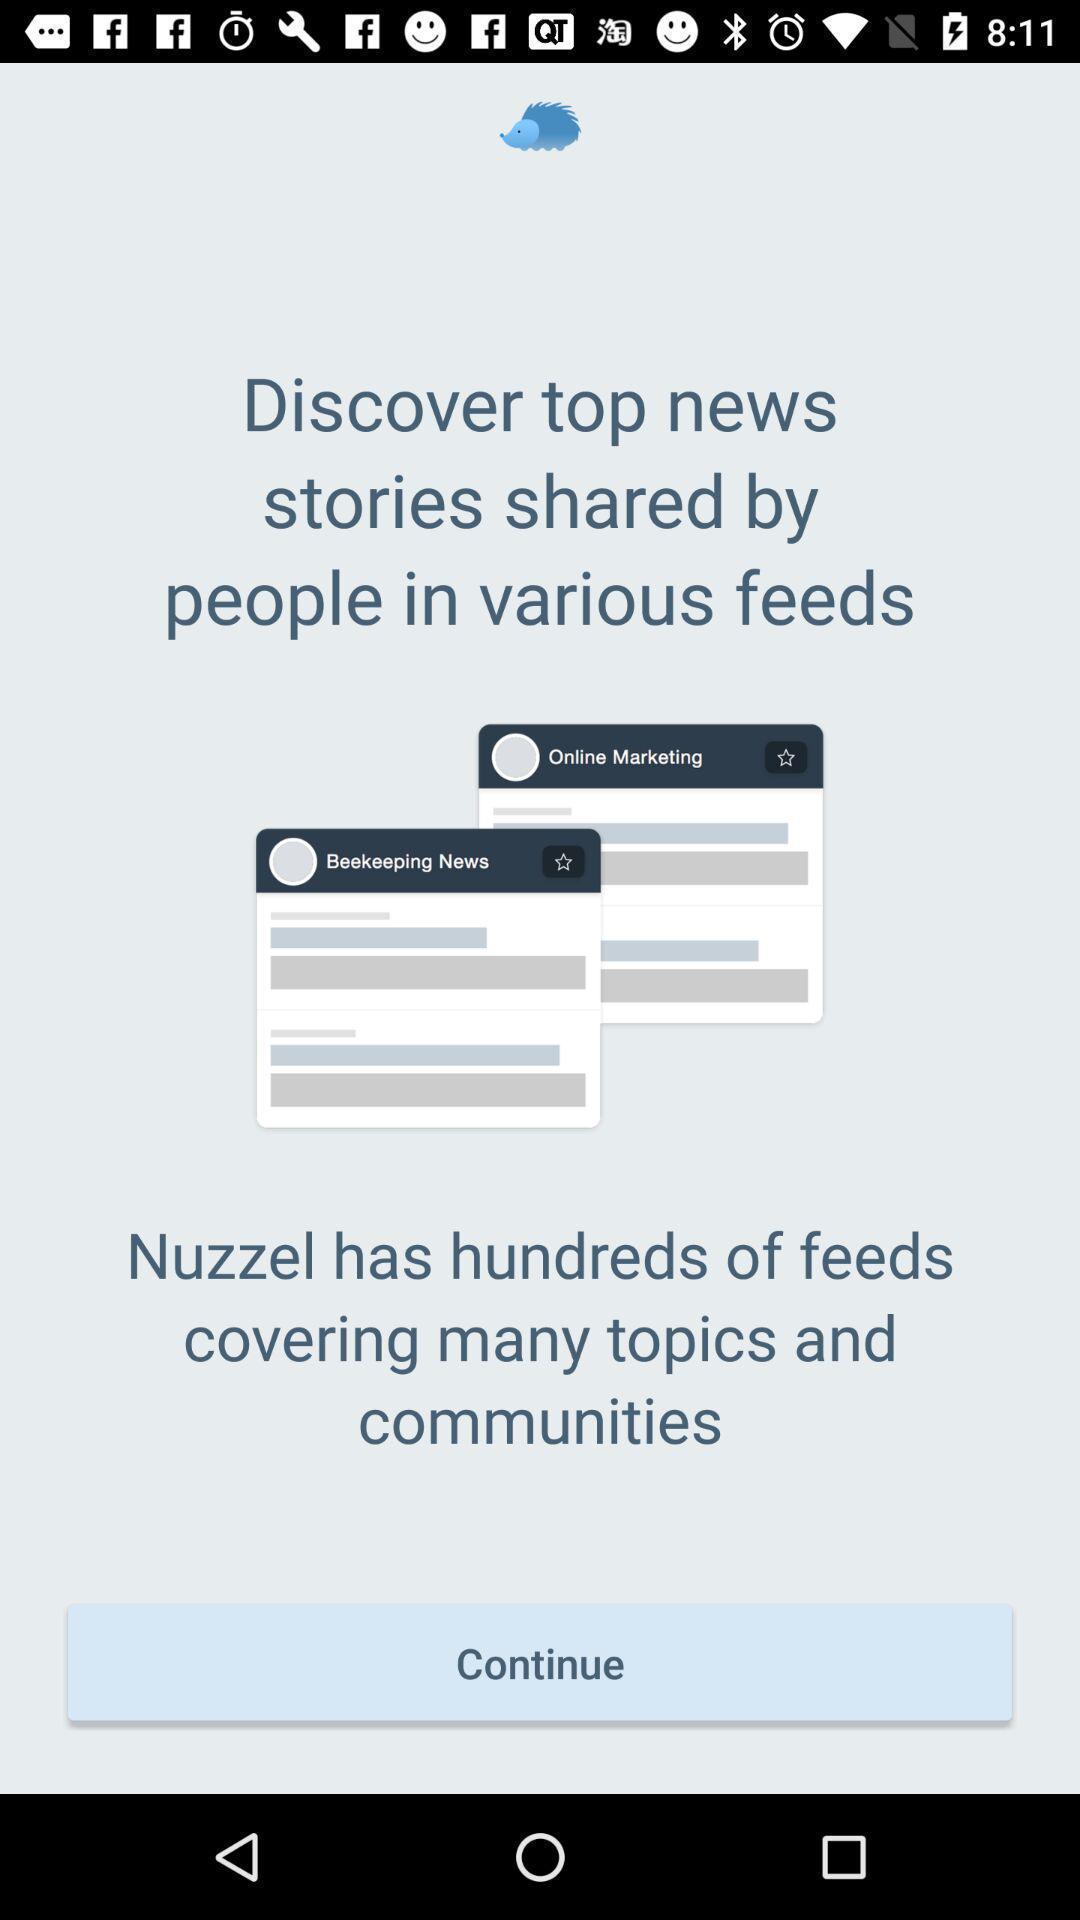Summarize the information in this screenshot. Welcome page with continue option. 